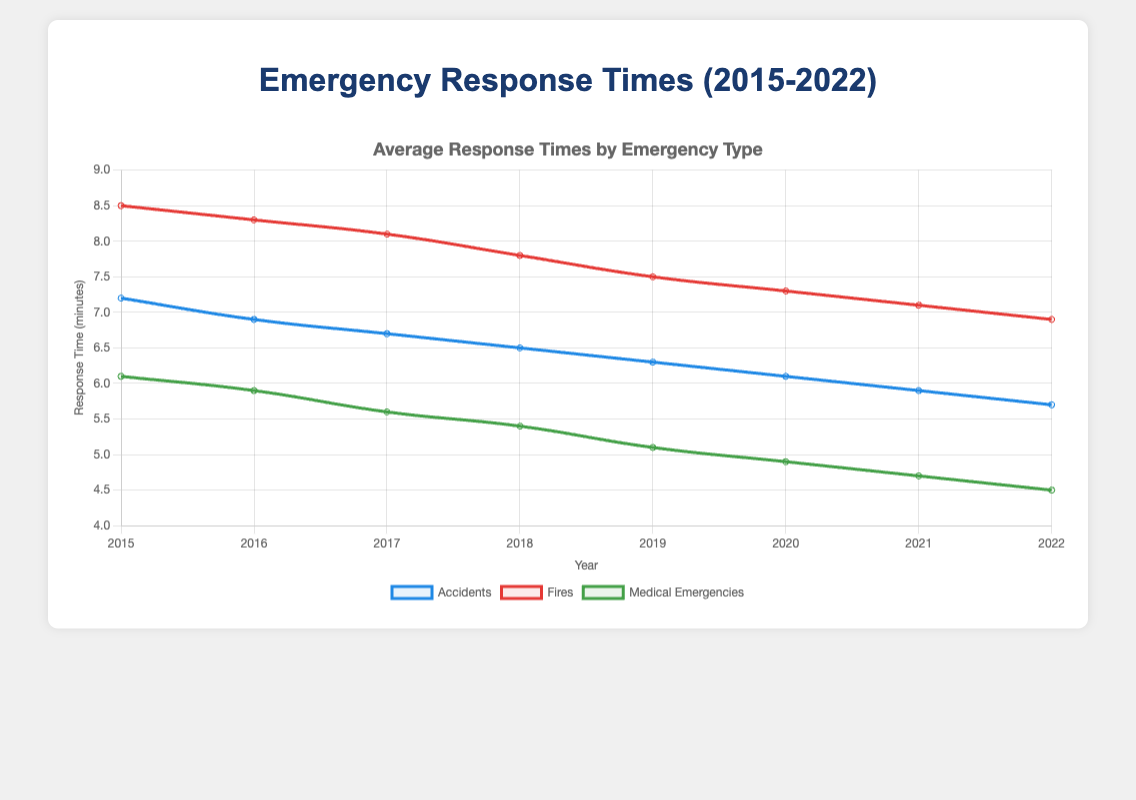What is the trend of average response times for medical emergencies from 2015 to 2022? By observing the plotted line representing average response times for medical emergencies, we can see the trend is generally decreasing each year from 2015 to 2022.
Answer: Decreasing How does the average response time for fires in 2022 compare to that in 2015? Look at the chart and compare the height of the line segments for fires in 2022 and 2015. The response time for fires in 2022 is lower than in 2015. The specific values are 6.9 minutes in 2022 and 8.5 minutes in 2015.
Answer: Lower In which year did accidents have the lowest average response time? Check the plotted points representing accidents and identify the year where the response time is the lowest. The lowest point on the accidents line is in 2022, with an average response time of 5.7 minutes.
Answer: 2022 What is the main difference in response time trends between fires and medical emergencies from 2018 to 2022? Compare the trend lines for fires and medical emergencies between 2018 and 2022. Fires show a consistent decrease, but medical emergencies show a steeper decline.
Answer: Fires decrease consistently, while medical emergencies drop more steeply What is the difference in the average response time for accidents between 2015 and 2020? Calculate the difference between the average response time for accidents for 2015 and 2020. The values are 7.2 minutes in 2015 and 6.1 minutes in 2020, so the difference is 7.2 - 6.1 = 1.1 minutes.
Answer: 1.1 minutes Which type of call had the lowest average response time in 2019? Compare the average response times in 2019 for each type of call and find the lowest value. Medical emergencies had the lowest average response time at 5.1 minutes.
Answer: Medical emergencies Calculate the average response time across all types of calls for the year 2017. The average response times for 2017 are 6.7 for accidents, 8.1 for fires, and 5.6 for medical emergencies. Calculate the mean: (6.7 + 8.1 + 5.6) / 3 = 20.4 / 3 = 6.8 minutes.
Answer: 6.8 minutes By what percentage did the average response time for accidents decrease from 2015 to 2022? Calculate the percentage decrease using the formula: [(initial value - final value) / initial value] * 100. Initial value (2015) = 7.2, final value (2022) = 5.7. Percentage decrease = [(7.2 - 5.7) / 7.2] * 100 ≈ 20.83%.
Answer: 20.83% In 2021, which type of call saw the smallest decrease in average response time compared to the previous year, 2020? Compare the differences in response times from 2020 to 2021 for each type of call. For accidents: 6.1 - 5.9 = 0.2 minutes. For fires: 7.3 - 7.1 = 0.2 minutes. For medical emergencies: 4.9 - 4.7 = 0.2 minutes. Since they are all equal, specify all types.
Answer: Accidents, fires, medical emergencies What is the total reduction in response time for accidents between 2015 and 2022? Calculate the reduction in response time for accidents from 2015 to 2022. Initial value (2015) = 7.2 minutes, final value (2022) = 5.7 minutes. Total reduction = 7.2 - 5.7 = 1.5 minutes.
Answer: 1.5 minutes 